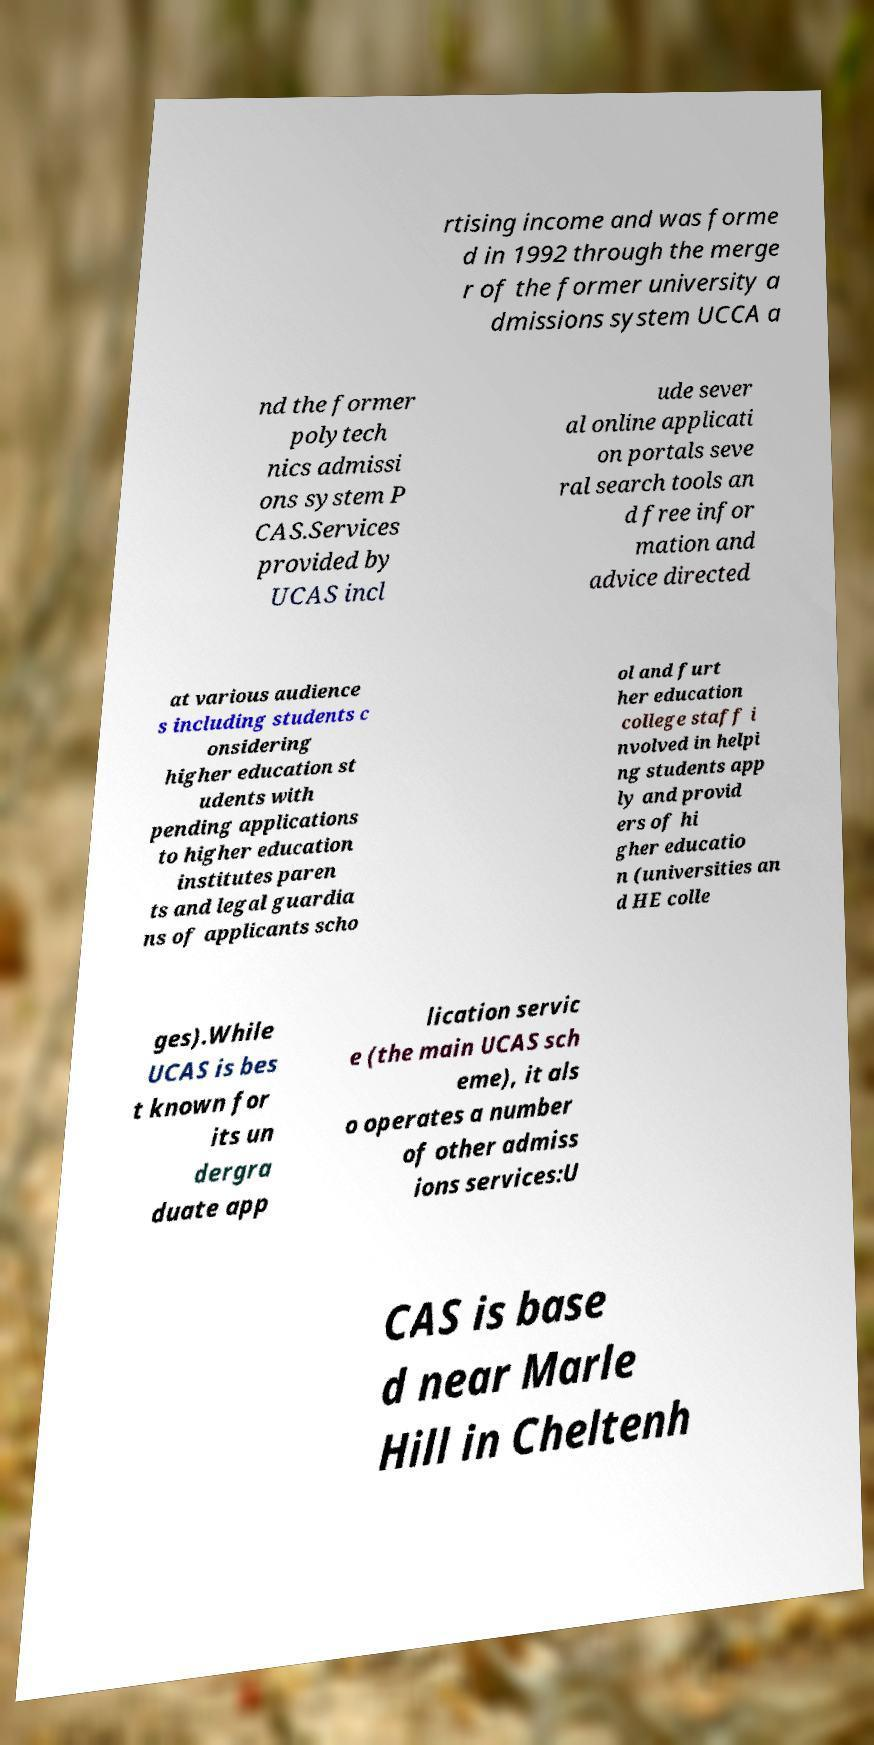Please read and relay the text visible in this image. What does it say? rtising income and was forme d in 1992 through the merge r of the former university a dmissions system UCCA a nd the former polytech nics admissi ons system P CAS.Services provided by UCAS incl ude sever al online applicati on portals seve ral search tools an d free infor mation and advice directed at various audience s including students c onsidering higher education st udents with pending applications to higher education institutes paren ts and legal guardia ns of applicants scho ol and furt her education college staff i nvolved in helpi ng students app ly and provid ers of hi gher educatio n (universities an d HE colle ges).While UCAS is bes t known for its un dergra duate app lication servic e (the main UCAS sch eme), it als o operates a number of other admiss ions services:U CAS is base d near Marle Hill in Cheltenh 